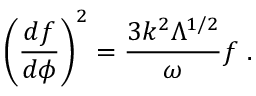Convert formula to latex. <formula><loc_0><loc_0><loc_500><loc_500>\left ( \frac { d f } { d \phi } \right ) ^ { 2 } = \frac { 3 k ^ { 2 } \Lambda ^ { 1 / 2 } } { \omega } f .</formula> 